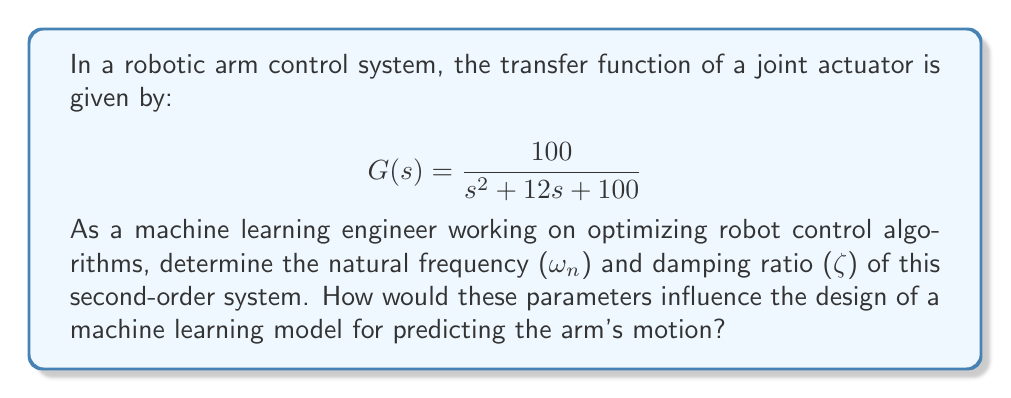Can you answer this question? To solve this problem, we'll follow these steps:

1) The general form of a second-order transfer function is:

   $$ G(s) = \frac{\omega_n^2}{s^2 + 2\zeta\omega_n s + \omega_n^2} $$

2) Comparing our given transfer function to the general form:

   $$ \frac{100}{s^2 + 12s + 100} = \frac{\omega_n^2}{s^2 + 2\zeta\omega_n s + \omega_n^2} $$

3) We can identify that:
   
   $\omega_n^2 = 100$
   $2\zeta\omega_n = 12$

4) To find $\omega_n$:
   
   $\omega_n = \sqrt{100} = 10$ rad/s

5) To find $\zeta$:
   
   $2\zeta\omega_n = 12$
   $2\zeta(10) = 12$
   $\zeta = \frac{12}{20} = 0.6$

6) Interpretation for machine learning model design:

   - The natural frequency ($\omega_n = 10$ rad/s) represents the frequency at which the system would oscillate if there were no damping. This informs the model about the system's speed of response.
   
   - The damping ratio ($\zeta = 0.6$) indicates that the system is underdamped (0 < $\zeta$ < 1). This means the system will oscillate with decreasing amplitude before settling.
   
   These parameters are crucial for a machine learning model predicting the arm's motion:
   
   - They help in feature engineering, as the model should consider these inherent system characteristics.
   - They inform the choice of sampling rate for data collection, which should be at least twice the natural frequency.
   - They guide the selection of the prediction horizon, as the settling time is related to these parameters.
   - Understanding these parameters helps in designing appropriate loss functions that account for the expected oscillatory behavior of the system.
Answer: Natural frequency: $\omega_n = 10$ rad/s
Damping ratio: $\zeta = 0.6$ 